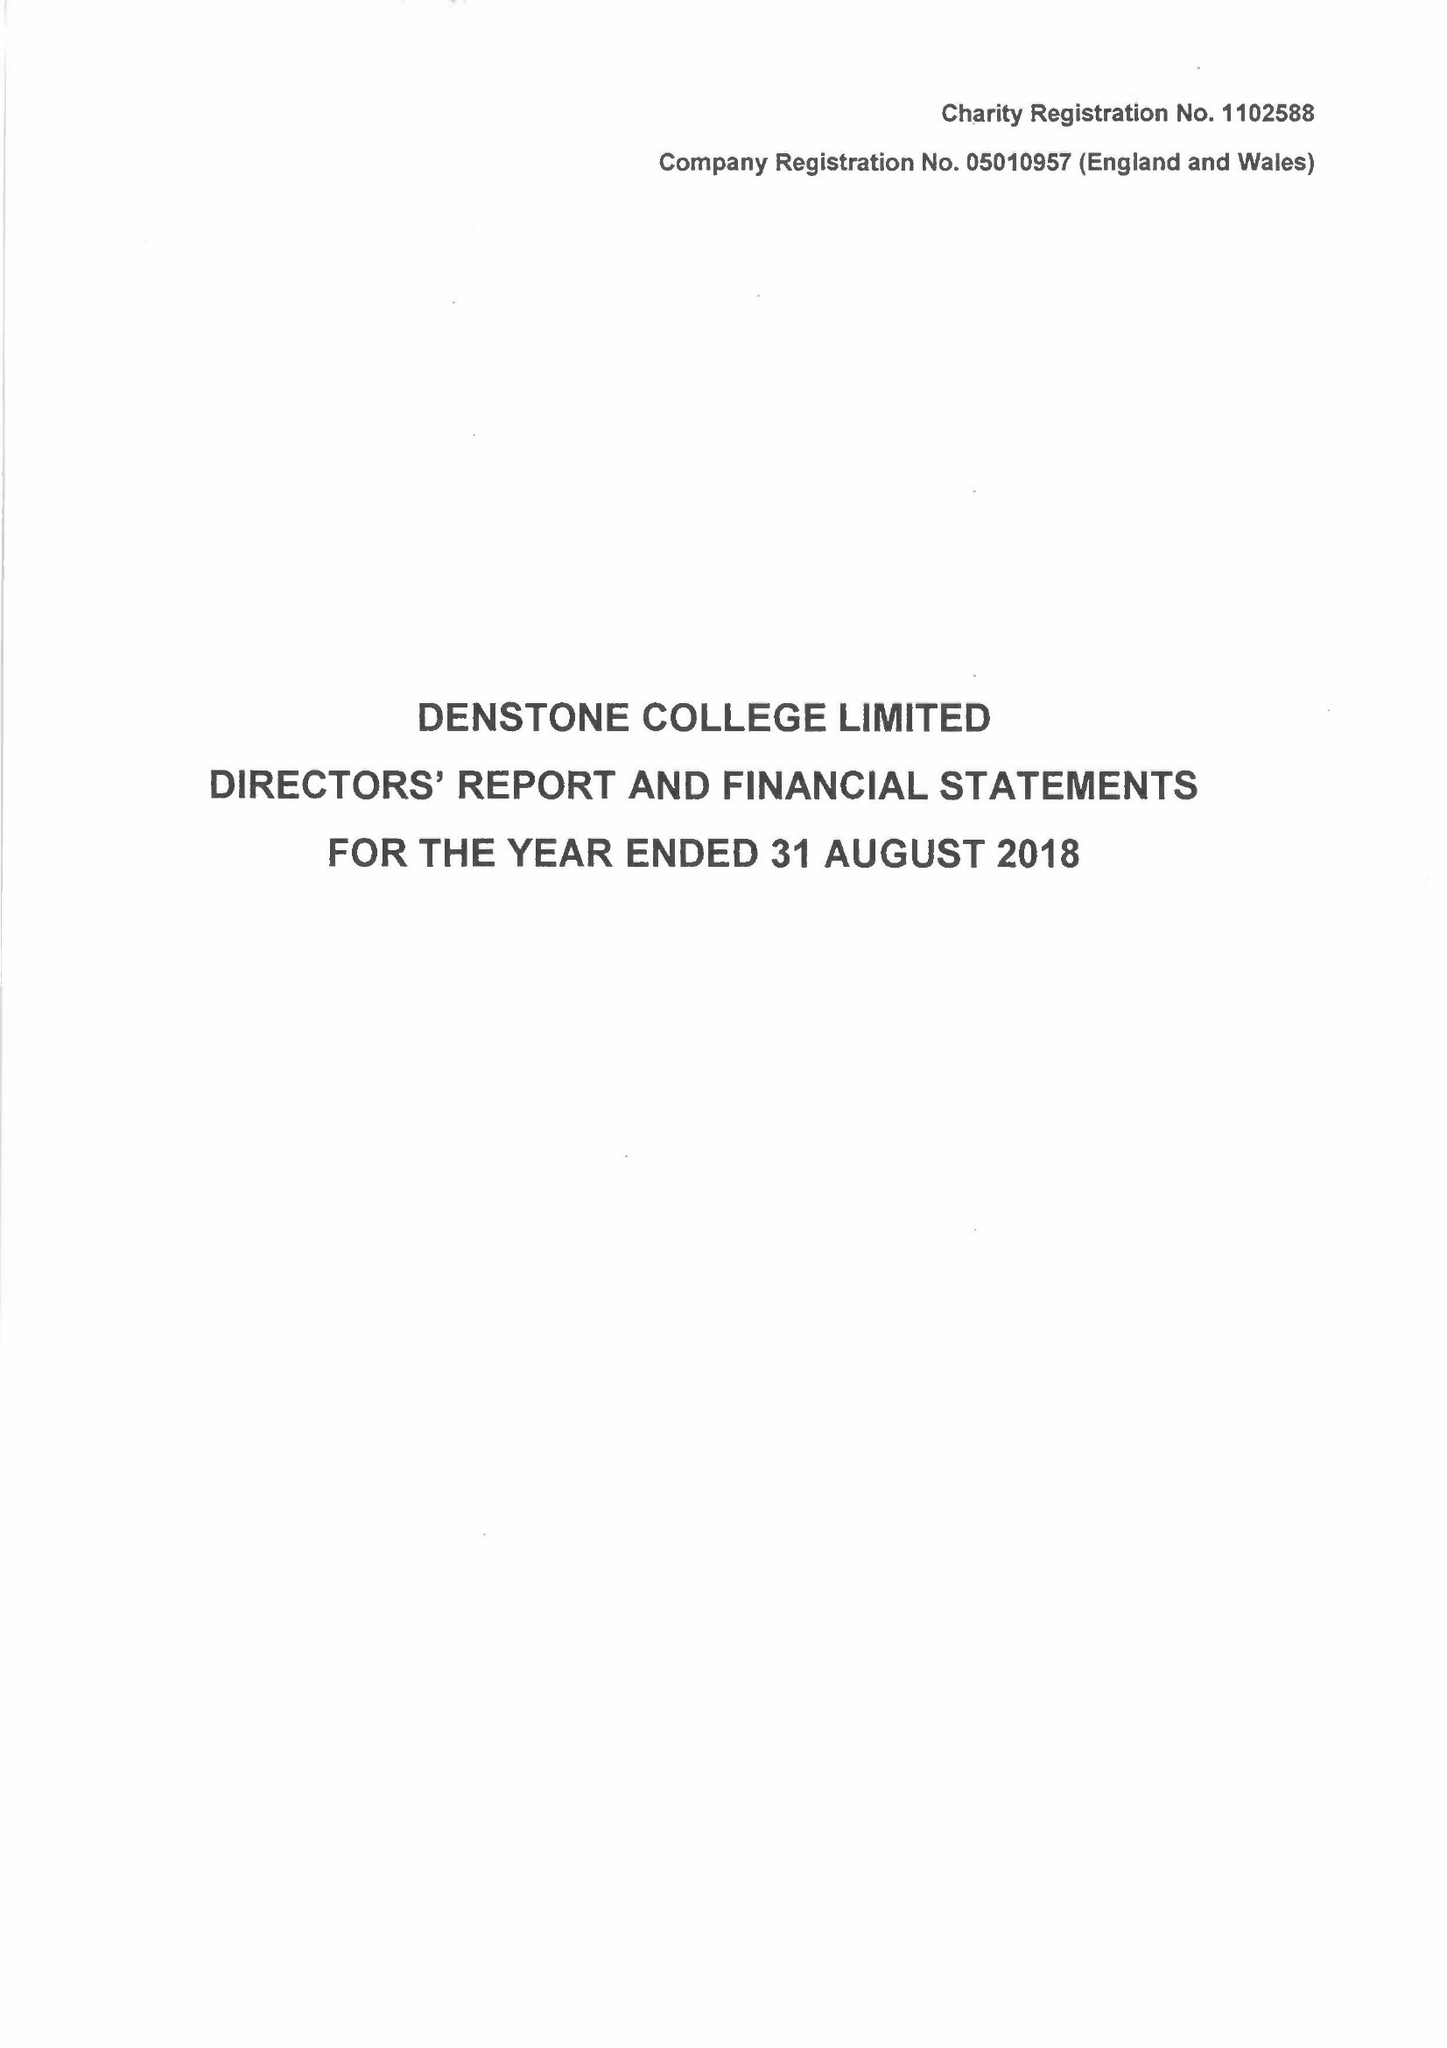What is the value for the address__street_line?
Answer the question using a single word or phrase. None 